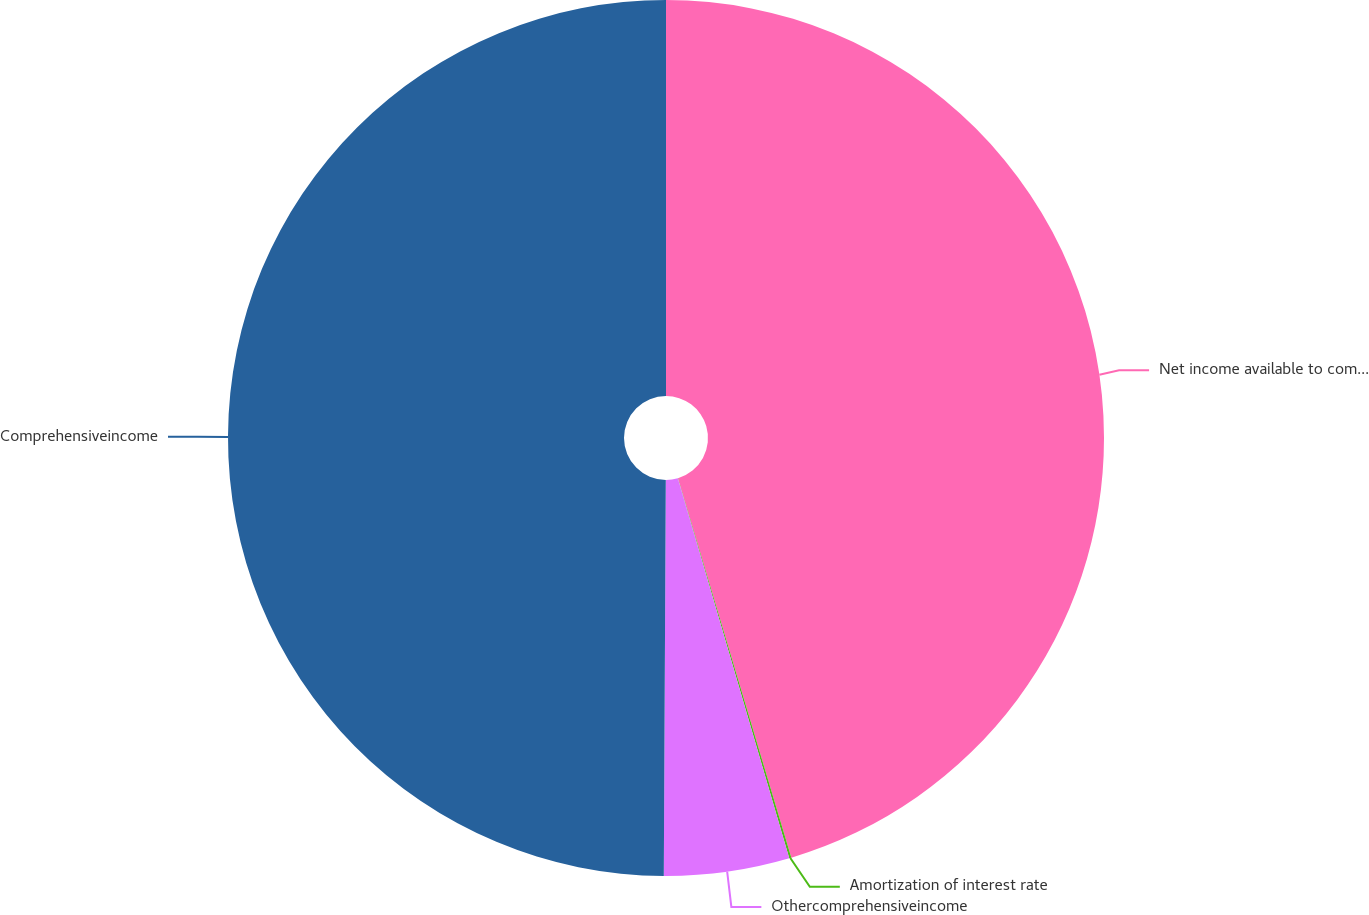Convert chart to OTSL. <chart><loc_0><loc_0><loc_500><loc_500><pie_chart><fcel>Net income available to common<fcel>Amortization of interest rate<fcel>Othercomprehensiveincome<fcel>Comprehensiveincome<nl><fcel>45.38%<fcel>0.08%<fcel>4.62%<fcel>49.92%<nl></chart> 